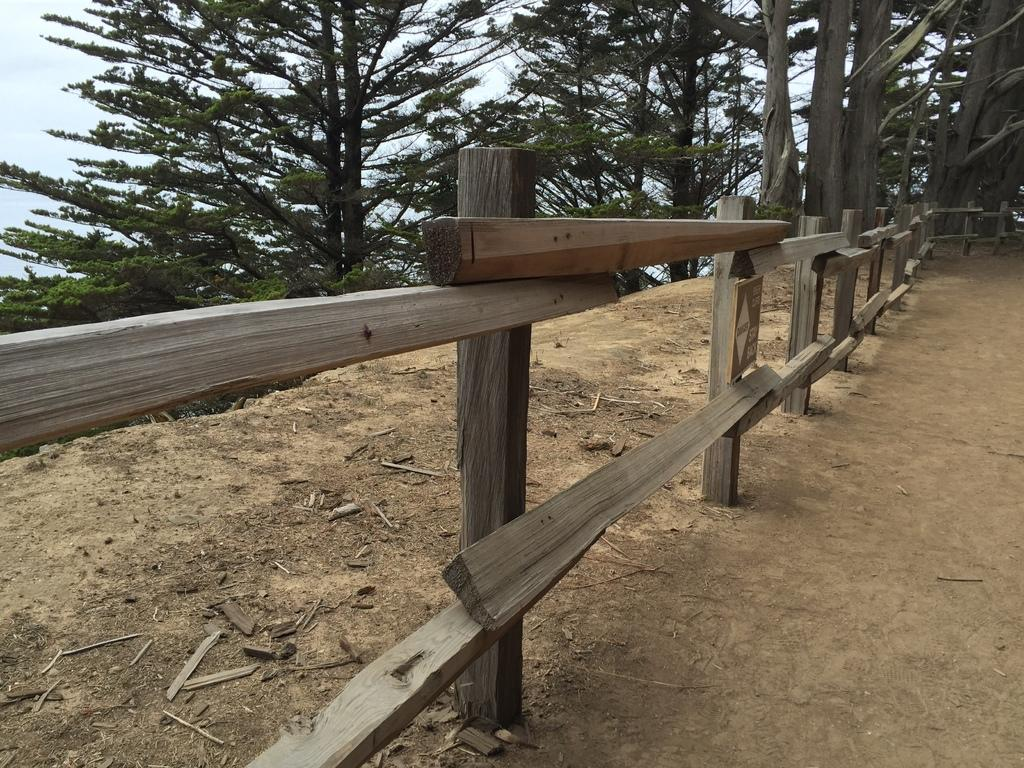What type of fence is visible in the image? There is a wooden fence in the image. What can be seen in the background of the image? There are trees in the background of the image. How many bananas are hanging from the wooden fence in the image? There are no bananas present in the image; it features a wooden fence and trees in the background. What type of shoes are the trees wearing in the image? Trees do not wear shoes, as they are not living beings capable of wearing clothing or accessories. 